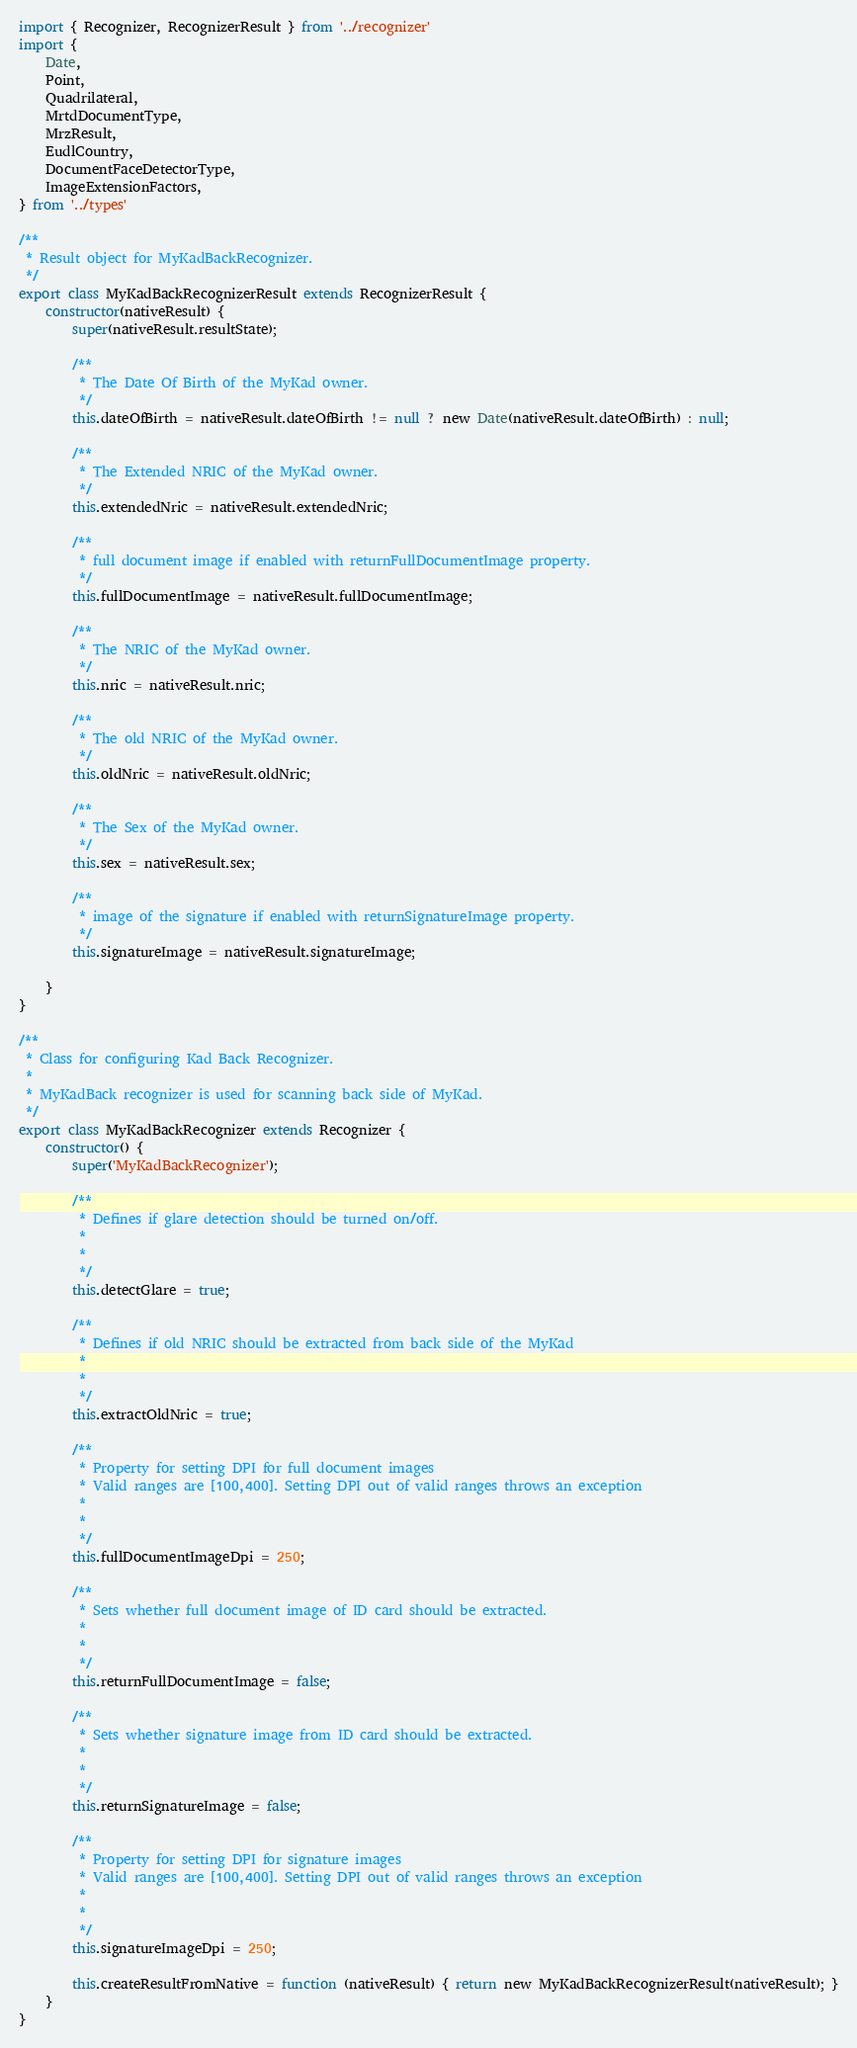<code> <loc_0><loc_0><loc_500><loc_500><_JavaScript_>import { Recognizer, RecognizerResult } from '../recognizer'
import {
    Date, 
    Point, 
    Quadrilateral,
    MrtdDocumentType, 
    MrzResult, 
    EudlCountry, 
    DocumentFaceDetectorType,
    ImageExtensionFactors,
} from '../types'

/**
 * Result object for MyKadBackRecognizer.
 */
export class MyKadBackRecognizerResult extends RecognizerResult {
    constructor(nativeResult) {
        super(nativeResult.resultState);
        
        /** 
         * The Date Of Birth of the MyKad owner. 
         */
        this.dateOfBirth = nativeResult.dateOfBirth != null ? new Date(nativeResult.dateOfBirth) : null;
        
        /** 
         * The Extended NRIC of the MyKad owner. 
         */
        this.extendedNric = nativeResult.extendedNric;
        
        /** 
         * full document image if enabled with returnFullDocumentImage property. 
         */
        this.fullDocumentImage = nativeResult.fullDocumentImage;
        
        /** 
         * The NRIC of the MyKad owner. 
         */
        this.nric = nativeResult.nric;
        
        /** 
         * The old NRIC of the MyKad owner. 
         */
        this.oldNric = nativeResult.oldNric;
        
        /** 
         * The Sex of the MyKad owner. 
         */
        this.sex = nativeResult.sex;
        
        /** 
         * image of the signature if enabled with returnSignatureImage property. 
         */
        this.signatureImage = nativeResult.signatureImage;
        
    }
}

/**
 * Class for configuring Kad Back Recognizer.
 * 
 * MyKadBack recognizer is used for scanning back side of MyKad.
 */
export class MyKadBackRecognizer extends Recognizer {
    constructor() {
        super('MyKadBackRecognizer');
        
        /** 
         * Defines if glare detection should be turned on/off.
         * 
         *  
         */
        this.detectGlare = true;
        
        /** 
         * Defines if old NRIC should be extracted from back side of the MyKad
         * 
         *  
         */
        this.extractOldNric = true;
        
        /** 
         * Property for setting DPI for full document images
         * Valid ranges are [100,400]. Setting DPI out of valid ranges throws an exception
         * 
         *  
         */
        this.fullDocumentImageDpi = 250;
        
        /** 
         * Sets whether full document image of ID card should be extracted.
         * 
         *  
         */
        this.returnFullDocumentImage = false;
        
        /** 
         * Sets whether signature image from ID card should be extracted.
         * 
         *  
         */
        this.returnSignatureImage = false;
        
        /** 
         * Property for setting DPI for signature images
         * Valid ranges are [100,400]. Setting DPI out of valid ranges throws an exception
         * 
         *  
         */
        this.signatureImageDpi = 250;
        
        this.createResultFromNative = function (nativeResult) { return new MyKadBackRecognizerResult(nativeResult); }
    }
}</code> 